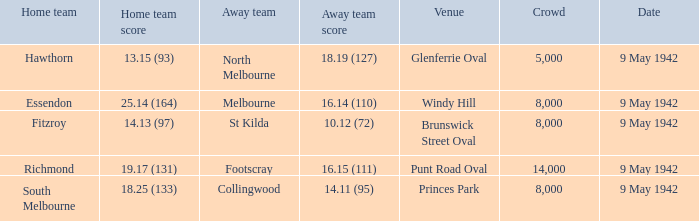How many people attended the game with the home team scoring 18.25 (133)? 1.0. 